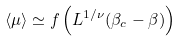<formula> <loc_0><loc_0><loc_500><loc_500>\langle \mu \rangle \simeq f \left ( L ^ { 1 / \nu } ( \beta _ { c } - \beta ) \right )</formula> 